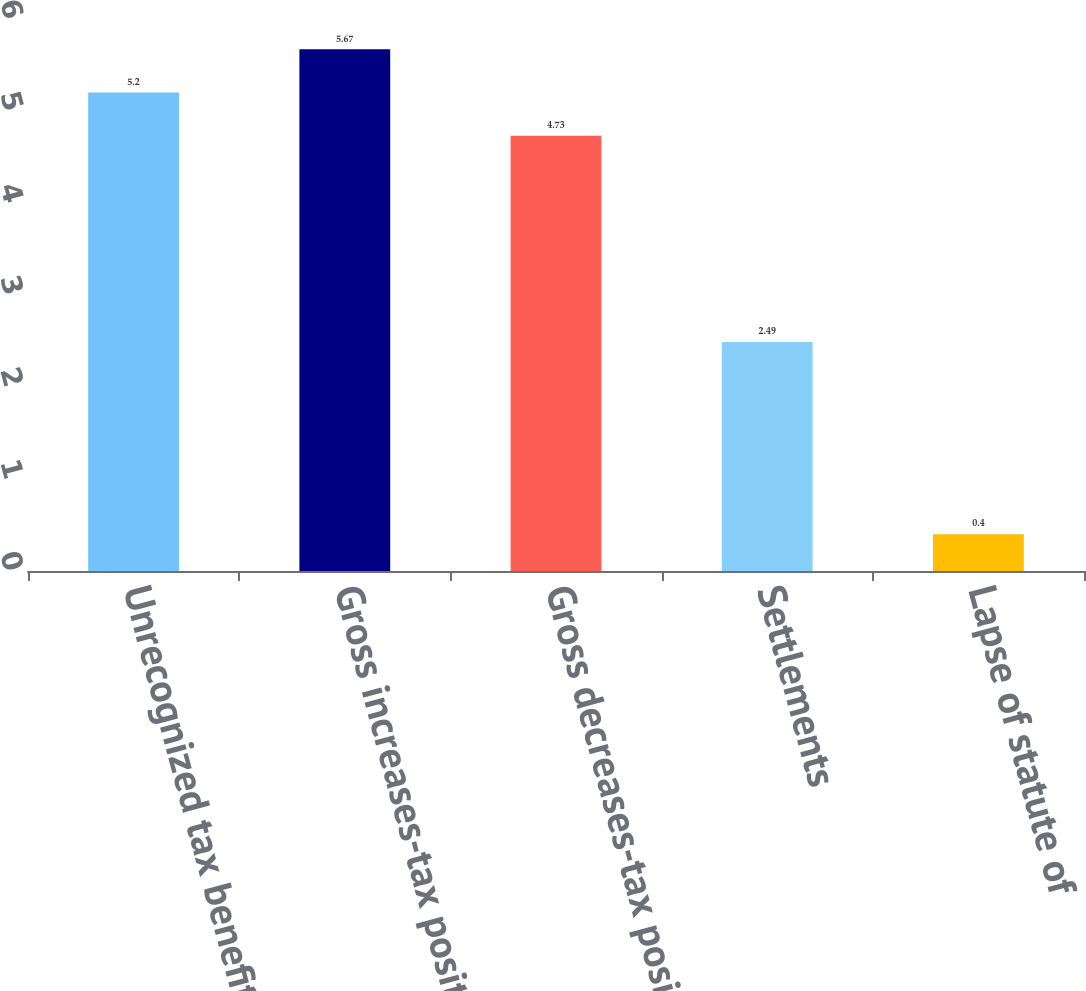Convert chart. <chart><loc_0><loc_0><loc_500><loc_500><bar_chart><fcel>Unrecognized tax benefits at<fcel>Gross increases-tax positions<fcel>Gross decreases-tax positions<fcel>Settlements<fcel>Lapse of statute of<nl><fcel>5.2<fcel>5.67<fcel>4.73<fcel>2.49<fcel>0.4<nl></chart> 